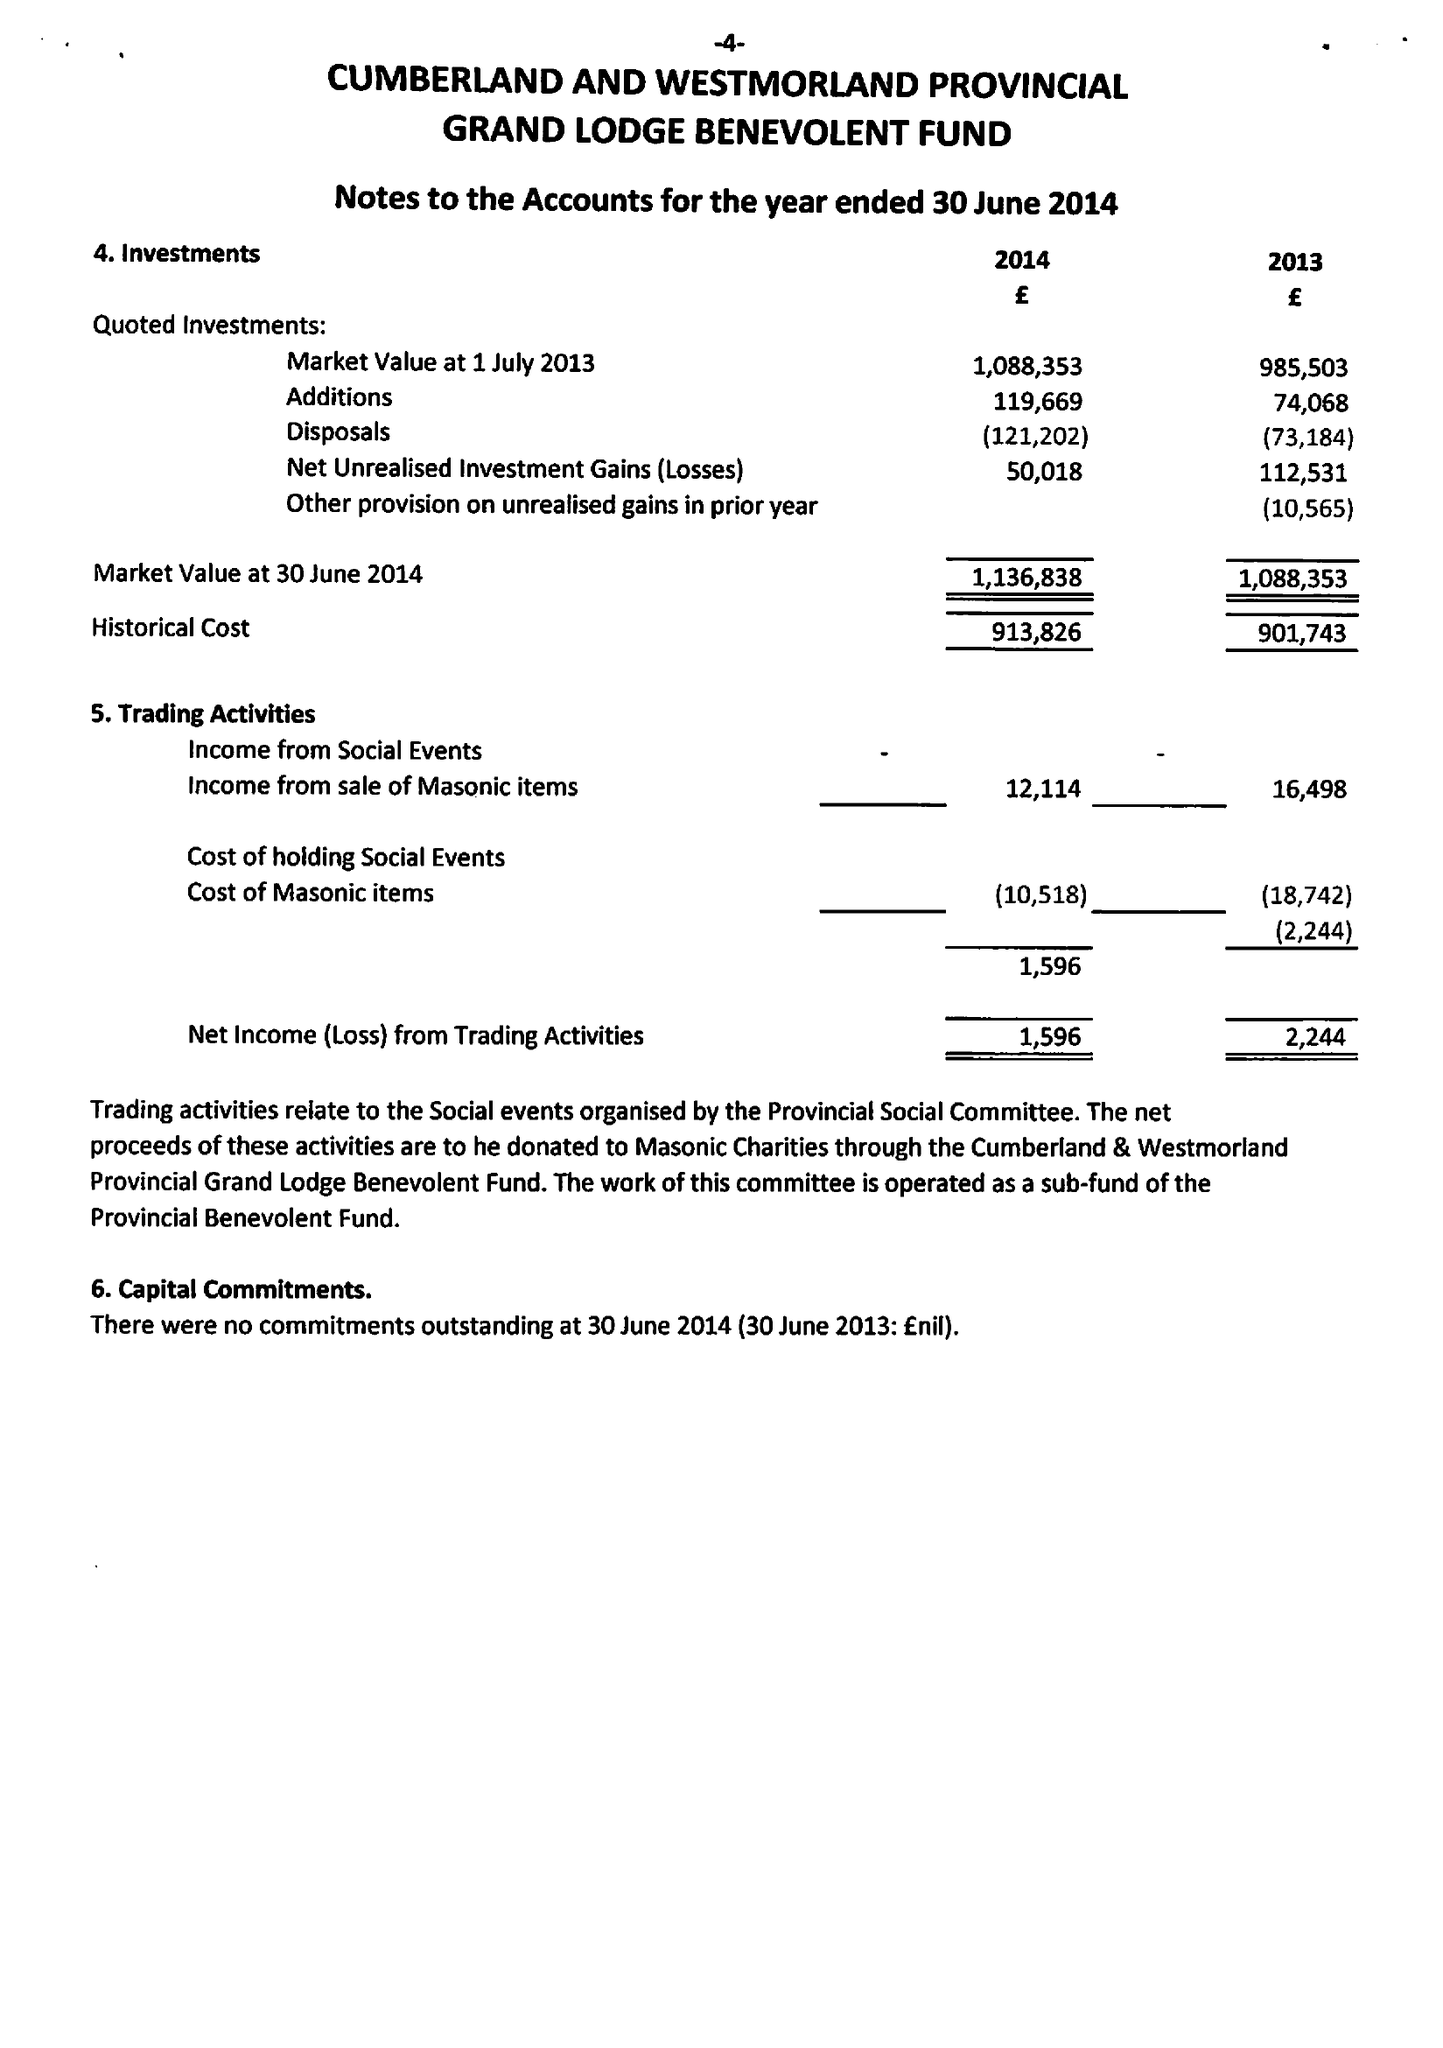What is the value for the spending_annually_in_british_pounds?
Answer the question using a single word or phrase. 90728.00 